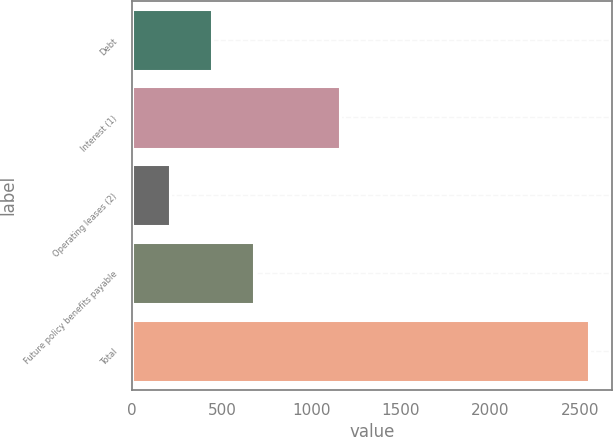Convert chart to OTSL. <chart><loc_0><loc_0><loc_500><loc_500><bar_chart><fcel>Debt<fcel>Interest (1)<fcel>Operating leases (2)<fcel>Future policy benefits payable<fcel>Total<nl><fcel>444.2<fcel>1161<fcel>210<fcel>678.4<fcel>2552<nl></chart> 